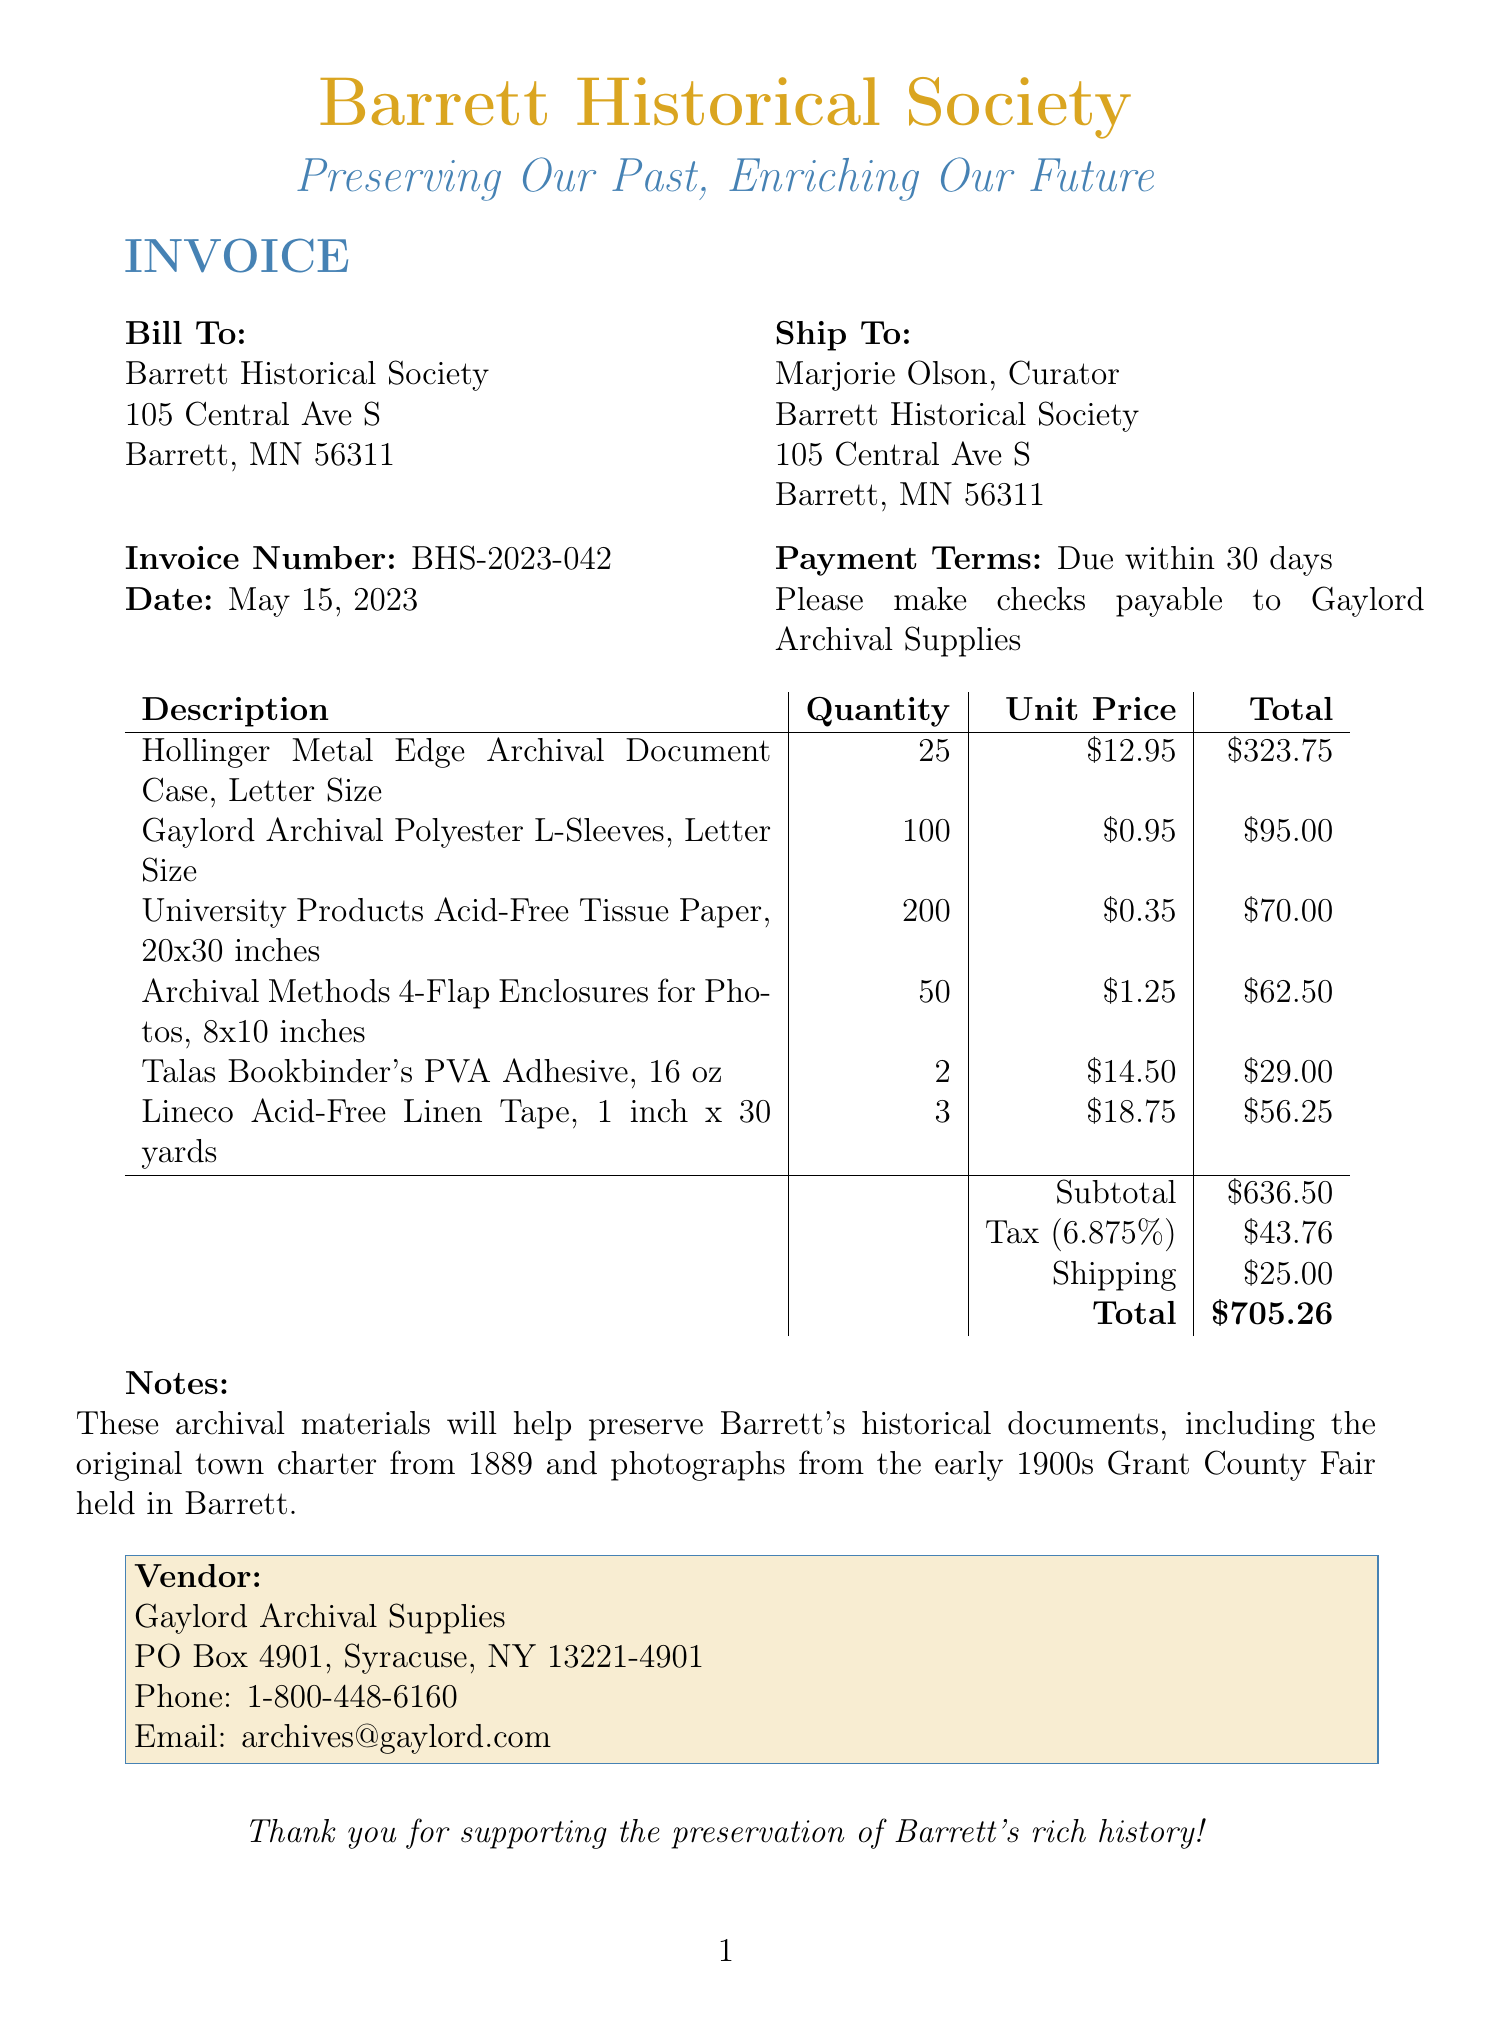What is the invoice number? The invoice number is a unique identifier for the document listed at the top.
Answer: BHS-2023-042 What is the date of the invoice? The date shows when the invoice was issued, located near the invoice number.
Answer: May 15, 2023 Who is the bill addressed to? The bill indicates the name and address of the entity being charged for the items.
Answer: Barrett Historical Society What is the total amount due on this invoice? The total amount is calculated by adding all line items, tax, and shipping together.
Answer: $705.26 How many Hollinger Metal Edge Archival Document Cases were purchased? This number is stated in the quantity column for that item on the invoice.
Answer: 25 What is the tax rate applied to this invoice? The tax rate is detailed under the subtotal in the invoice breakdown.
Answer: 6.875% What is the subtotal before tax and shipping? The subtotal is the sum of all item totals listed above the tax amount.
Answer: $636.50 What is the shipping cost included in the total? The shipping cost is listed in the invoice breakdown, affecting the final amount due.
Answer: $25.00 What is the name of the vendor? The vendor is the company from which the archival materials were purchased, mentioned in the vendor section.
Answer: Gaylord Archival Supplies 